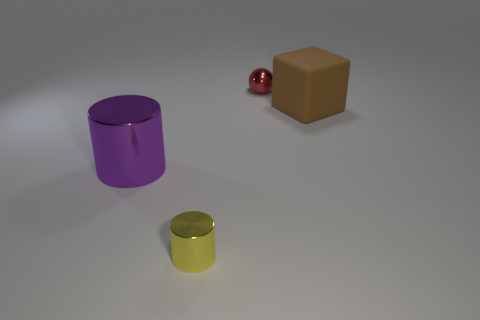Is there a yellow thing of the same shape as the large purple thing?
Provide a succinct answer. Yes. How many big brown rubber things are in front of the big cube?
Your answer should be very brief. 0. There is a purple object that is left of the tiny object behind the large metallic object; what is its material?
Make the answer very short. Metal. There is a brown object that is the same size as the purple metal object; what is it made of?
Make the answer very short. Rubber. Is there a cylinder of the same size as the rubber block?
Offer a very short reply. Yes. The small metal object in front of the red metal sphere is what color?
Offer a terse response. Yellow. Is there a purple cylinder that is to the right of the tiny object in front of the small ball?
Make the answer very short. No. What number of other objects are there of the same color as the tiny metal ball?
Keep it short and to the point. 0. There is a metallic thing behind the large brown thing; is it the same size as the object that is right of the red metal thing?
Make the answer very short. No. There is a metallic cylinder on the right side of the large metal cylinder to the left of the brown matte cube; what is its size?
Offer a terse response. Small. 